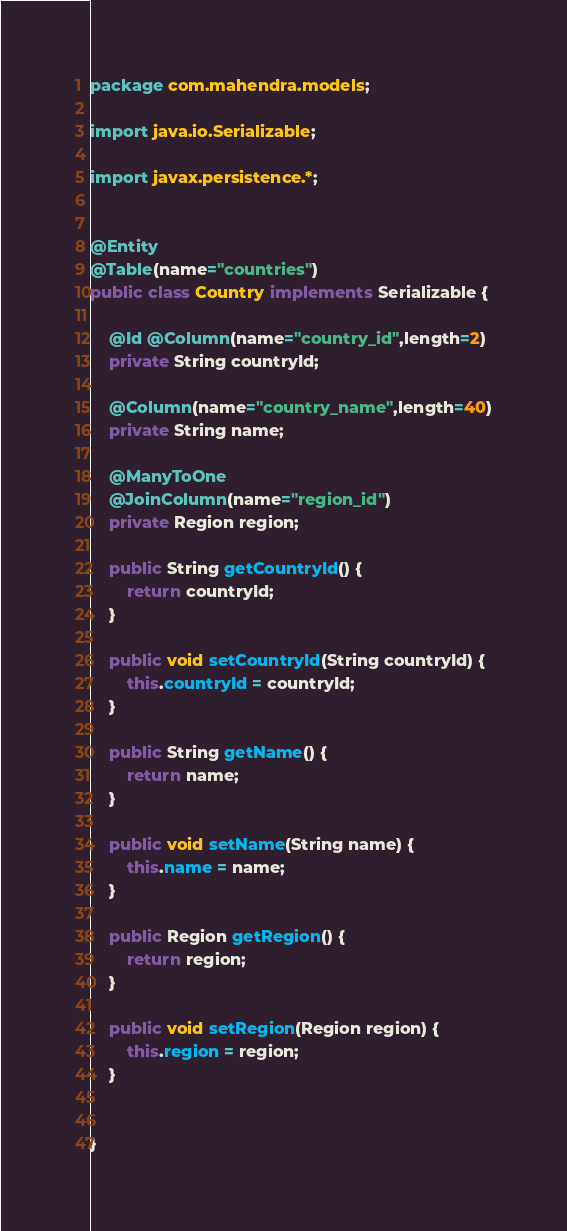Convert code to text. <code><loc_0><loc_0><loc_500><loc_500><_Java_>package com.mahendra.models;

import java.io.Serializable;

import javax.persistence.*;


@Entity
@Table(name="countries")
public class Country implements Serializable {

	@Id @Column(name="country_id",length=2)
	private String countryId;
	
	@Column(name="country_name",length=40)
	private String name;
	
	@ManyToOne
	@JoinColumn(name="region_id")
	private Region region;

	public String getCountryId() {
		return countryId;
	}

	public void setCountryId(String countryId) {
		this.countryId = countryId;
	}

	public String getName() {
		return name;
	}

	public void setName(String name) {
		this.name = name;
	}

	public Region getRegion() {
		return region;
	}

	public void setRegion(Region region) {
		this.region = region;
	}
	
	
}
</code> 